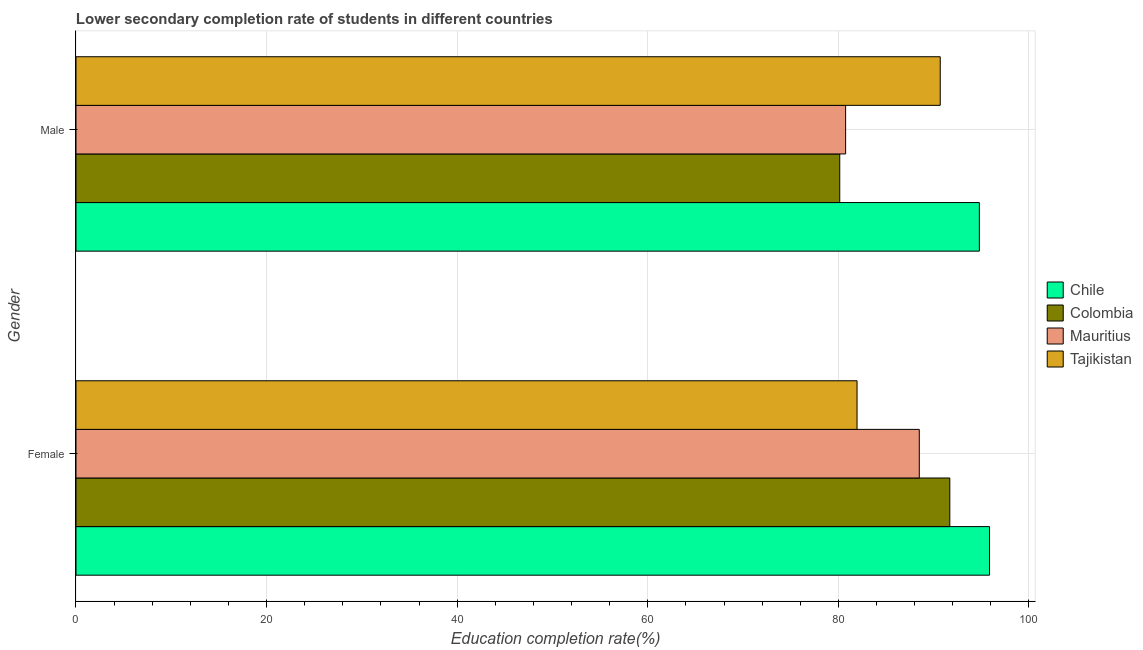Are the number of bars per tick equal to the number of legend labels?
Provide a short and direct response. Yes. How many bars are there on the 1st tick from the top?
Your response must be concise. 4. How many bars are there on the 2nd tick from the bottom?
Your answer should be very brief. 4. What is the education completion rate of female students in Tajikistan?
Your answer should be very brief. 81.96. Across all countries, what is the maximum education completion rate of female students?
Your answer should be very brief. 95.87. Across all countries, what is the minimum education completion rate of female students?
Keep it short and to the point. 81.96. In which country was the education completion rate of female students minimum?
Make the answer very short. Tajikistan. What is the total education completion rate of male students in the graph?
Give a very brief answer. 346.4. What is the difference between the education completion rate of female students in Tajikistan and that in Colombia?
Keep it short and to the point. -9.74. What is the difference between the education completion rate of female students in Mauritius and the education completion rate of male students in Tajikistan?
Give a very brief answer. -2.2. What is the average education completion rate of male students per country?
Your response must be concise. 86.6. What is the difference between the education completion rate of male students and education completion rate of female students in Tajikistan?
Offer a very short reply. 8.73. In how many countries, is the education completion rate of female students greater than 96 %?
Provide a succinct answer. 0. What is the ratio of the education completion rate of female students in Chile to that in Mauritius?
Ensure brevity in your answer.  1.08. Is the education completion rate of male students in Colombia less than that in Mauritius?
Your response must be concise. Yes. What does the 1st bar from the bottom in Female represents?
Your response must be concise. Chile. How many bars are there?
Your response must be concise. 8. Are all the bars in the graph horizontal?
Provide a short and direct response. Yes. Where does the legend appear in the graph?
Provide a succinct answer. Center right. How are the legend labels stacked?
Provide a short and direct response. Vertical. What is the title of the graph?
Your answer should be compact. Lower secondary completion rate of students in different countries. What is the label or title of the X-axis?
Your answer should be very brief. Education completion rate(%). What is the label or title of the Y-axis?
Your answer should be compact. Gender. What is the Education completion rate(%) of Chile in Female?
Your answer should be very brief. 95.87. What is the Education completion rate(%) in Colombia in Female?
Ensure brevity in your answer.  91.7. What is the Education completion rate(%) in Mauritius in Female?
Provide a short and direct response. 88.49. What is the Education completion rate(%) of Tajikistan in Female?
Offer a very short reply. 81.96. What is the Education completion rate(%) in Chile in Male?
Offer a terse response. 94.8. What is the Education completion rate(%) of Colombia in Male?
Your response must be concise. 80.15. What is the Education completion rate(%) in Mauritius in Male?
Provide a succinct answer. 80.76. What is the Education completion rate(%) of Tajikistan in Male?
Provide a short and direct response. 90.69. Across all Gender, what is the maximum Education completion rate(%) of Chile?
Keep it short and to the point. 95.87. Across all Gender, what is the maximum Education completion rate(%) of Colombia?
Give a very brief answer. 91.7. Across all Gender, what is the maximum Education completion rate(%) in Mauritius?
Ensure brevity in your answer.  88.49. Across all Gender, what is the maximum Education completion rate(%) of Tajikistan?
Offer a terse response. 90.69. Across all Gender, what is the minimum Education completion rate(%) of Chile?
Give a very brief answer. 94.8. Across all Gender, what is the minimum Education completion rate(%) of Colombia?
Provide a short and direct response. 80.15. Across all Gender, what is the minimum Education completion rate(%) in Mauritius?
Keep it short and to the point. 80.76. Across all Gender, what is the minimum Education completion rate(%) in Tajikistan?
Ensure brevity in your answer.  81.96. What is the total Education completion rate(%) of Chile in the graph?
Give a very brief answer. 190.66. What is the total Education completion rate(%) of Colombia in the graph?
Offer a terse response. 171.85. What is the total Education completion rate(%) in Mauritius in the graph?
Your response must be concise. 169.26. What is the total Education completion rate(%) of Tajikistan in the graph?
Keep it short and to the point. 172.65. What is the difference between the Education completion rate(%) in Chile in Female and that in Male?
Your answer should be compact. 1.07. What is the difference between the Education completion rate(%) of Colombia in Female and that in Male?
Keep it short and to the point. 11.55. What is the difference between the Education completion rate(%) of Mauritius in Female and that in Male?
Your answer should be compact. 7.73. What is the difference between the Education completion rate(%) of Tajikistan in Female and that in Male?
Your response must be concise. -8.73. What is the difference between the Education completion rate(%) in Chile in Female and the Education completion rate(%) in Colombia in Male?
Your response must be concise. 15.72. What is the difference between the Education completion rate(%) of Chile in Female and the Education completion rate(%) of Mauritius in Male?
Give a very brief answer. 15.1. What is the difference between the Education completion rate(%) of Chile in Female and the Education completion rate(%) of Tajikistan in Male?
Offer a very short reply. 5.17. What is the difference between the Education completion rate(%) of Colombia in Female and the Education completion rate(%) of Mauritius in Male?
Make the answer very short. 10.93. What is the difference between the Education completion rate(%) in Colombia in Female and the Education completion rate(%) in Tajikistan in Male?
Your response must be concise. 1.01. What is the difference between the Education completion rate(%) in Mauritius in Female and the Education completion rate(%) in Tajikistan in Male?
Ensure brevity in your answer.  -2.2. What is the average Education completion rate(%) in Chile per Gender?
Your response must be concise. 95.33. What is the average Education completion rate(%) of Colombia per Gender?
Your response must be concise. 85.92. What is the average Education completion rate(%) in Mauritius per Gender?
Your answer should be very brief. 84.63. What is the average Education completion rate(%) in Tajikistan per Gender?
Your answer should be compact. 86.33. What is the difference between the Education completion rate(%) of Chile and Education completion rate(%) of Colombia in Female?
Provide a succinct answer. 4.17. What is the difference between the Education completion rate(%) of Chile and Education completion rate(%) of Mauritius in Female?
Offer a very short reply. 7.37. What is the difference between the Education completion rate(%) in Chile and Education completion rate(%) in Tajikistan in Female?
Make the answer very short. 13.9. What is the difference between the Education completion rate(%) of Colombia and Education completion rate(%) of Mauritius in Female?
Offer a very short reply. 3.2. What is the difference between the Education completion rate(%) of Colombia and Education completion rate(%) of Tajikistan in Female?
Your answer should be very brief. 9.74. What is the difference between the Education completion rate(%) in Mauritius and Education completion rate(%) in Tajikistan in Female?
Provide a short and direct response. 6.53. What is the difference between the Education completion rate(%) in Chile and Education completion rate(%) in Colombia in Male?
Your response must be concise. 14.65. What is the difference between the Education completion rate(%) of Chile and Education completion rate(%) of Mauritius in Male?
Provide a succinct answer. 14.03. What is the difference between the Education completion rate(%) in Chile and Education completion rate(%) in Tajikistan in Male?
Your response must be concise. 4.11. What is the difference between the Education completion rate(%) in Colombia and Education completion rate(%) in Mauritius in Male?
Give a very brief answer. -0.62. What is the difference between the Education completion rate(%) of Colombia and Education completion rate(%) of Tajikistan in Male?
Your answer should be compact. -10.54. What is the difference between the Education completion rate(%) of Mauritius and Education completion rate(%) of Tajikistan in Male?
Your response must be concise. -9.93. What is the ratio of the Education completion rate(%) of Chile in Female to that in Male?
Ensure brevity in your answer.  1.01. What is the ratio of the Education completion rate(%) of Colombia in Female to that in Male?
Your answer should be compact. 1.14. What is the ratio of the Education completion rate(%) of Mauritius in Female to that in Male?
Your answer should be very brief. 1.1. What is the ratio of the Education completion rate(%) in Tajikistan in Female to that in Male?
Provide a short and direct response. 0.9. What is the difference between the highest and the second highest Education completion rate(%) of Chile?
Provide a short and direct response. 1.07. What is the difference between the highest and the second highest Education completion rate(%) of Colombia?
Offer a terse response. 11.55. What is the difference between the highest and the second highest Education completion rate(%) of Mauritius?
Offer a terse response. 7.73. What is the difference between the highest and the second highest Education completion rate(%) in Tajikistan?
Provide a succinct answer. 8.73. What is the difference between the highest and the lowest Education completion rate(%) in Chile?
Ensure brevity in your answer.  1.07. What is the difference between the highest and the lowest Education completion rate(%) in Colombia?
Provide a succinct answer. 11.55. What is the difference between the highest and the lowest Education completion rate(%) in Mauritius?
Give a very brief answer. 7.73. What is the difference between the highest and the lowest Education completion rate(%) of Tajikistan?
Your answer should be very brief. 8.73. 